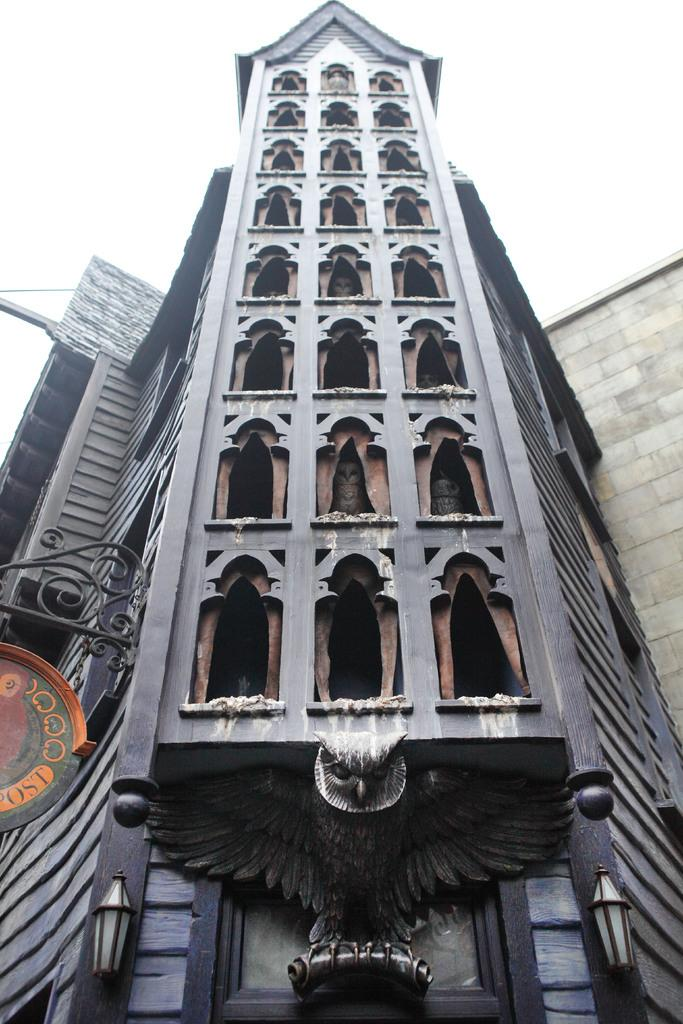What is the main structure in the image? There is a building in the image. Are there any specific features of the building? Yes, the building has 2 lamps. What type of decoration is present at the bottom of the building? There is an owl sculpture at the bottom of the building. How many passengers are waiting for the bus in the image? There is no bus or passengers present in the image; it only features a building with lamps and an owl sculpture. What type of wood is used to make the owl sculpture? The image does not provide information about the material used to make the owl sculpture. 